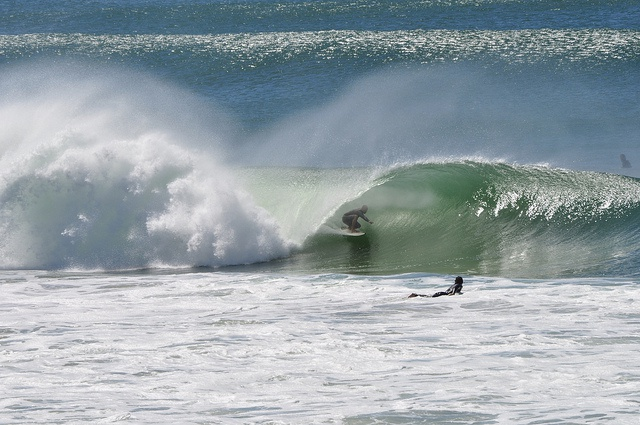Describe the objects in this image and their specific colors. I can see people in gray and black tones, people in gray, black, darkgray, and lightgray tones, surfboard in gray, darkgray, and black tones, people in gray tones, and surfboard in white, gray, and lightgray tones in this image. 